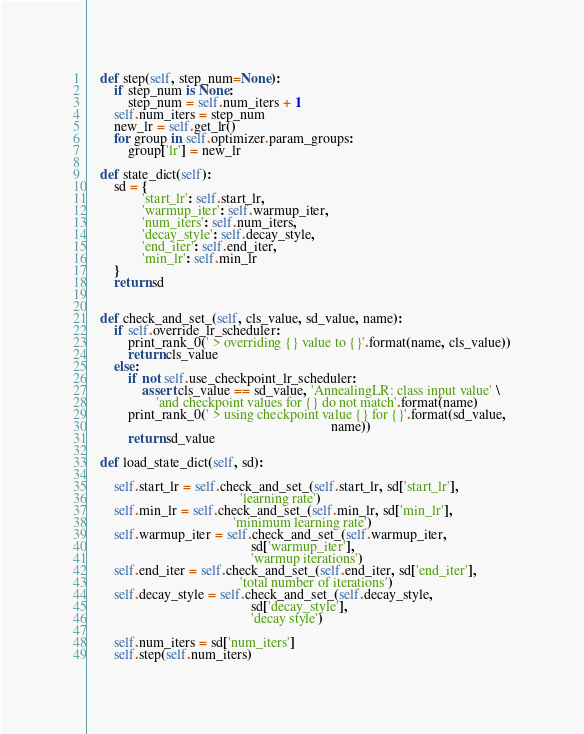<code> <loc_0><loc_0><loc_500><loc_500><_Python_>
    def step(self, step_num=None):
        if step_num is None:
            step_num = self.num_iters + 1
        self.num_iters = step_num
        new_lr = self.get_lr()
        for group in self.optimizer.param_groups:
            group['lr'] = new_lr

    def state_dict(self):
        sd = {
                'start_lr': self.start_lr,
                'warmup_iter': self.warmup_iter,
                'num_iters': self.num_iters,
                'decay_style': self.decay_style,
                'end_iter': self.end_iter,
                'min_lr': self.min_lr
        }
        return sd


    def check_and_set_(self, cls_value, sd_value, name):
        if self.override_lr_scheduler:
            print_rank_0(' > overriding {} value to {}'.format(name, cls_value))
            return cls_value
        else:
            if not self.use_checkpoint_lr_scheduler:
                assert cls_value == sd_value, 'AnnealingLR: class input value' \
                    'and checkpoint values for {} do not match'.format(name)
            print_rank_0(' > using checkpoint value {} for {}'.format(sd_value,
                                                                      name))
            return sd_value

    def load_state_dict(self, sd):

        self.start_lr = self.check_and_set_(self.start_lr, sd['start_lr'],
                                            'learning rate')
        self.min_lr = self.check_and_set_(self.min_lr, sd['min_lr'],
                                          'minimum learning rate')
        self.warmup_iter = self.check_and_set_(self.warmup_iter,
                                               sd['warmup_iter'],
                                               'warmup iterations')
        self.end_iter = self.check_and_set_(self.end_iter, sd['end_iter'],
                                            'total number of iterations')
        self.decay_style = self.check_and_set_(self.decay_style,
                                               sd['decay_style'],
                                               'decay style')

        self.num_iters = sd['num_iters']
        self.step(self.num_iters)
</code> 